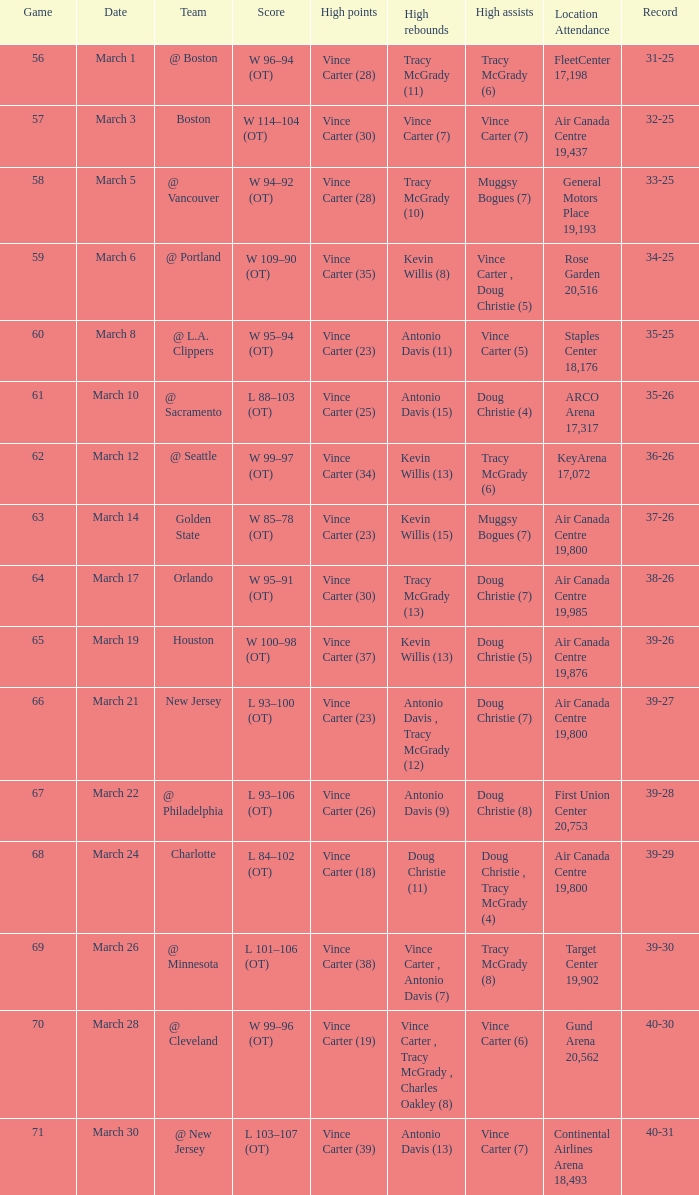What is the count of people with high assists @ minnesota? 1.0. 